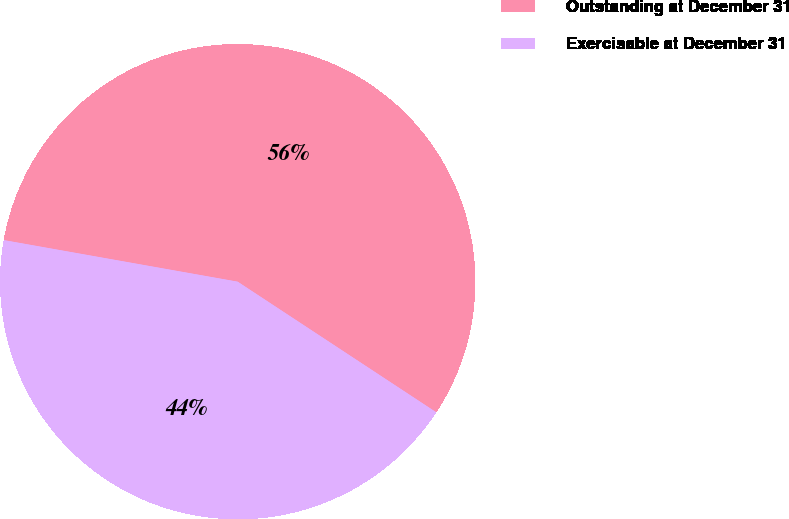<chart> <loc_0><loc_0><loc_500><loc_500><pie_chart><fcel>Outstanding at December 31<fcel>Exercisable at December 31<nl><fcel>56.46%<fcel>43.54%<nl></chart> 